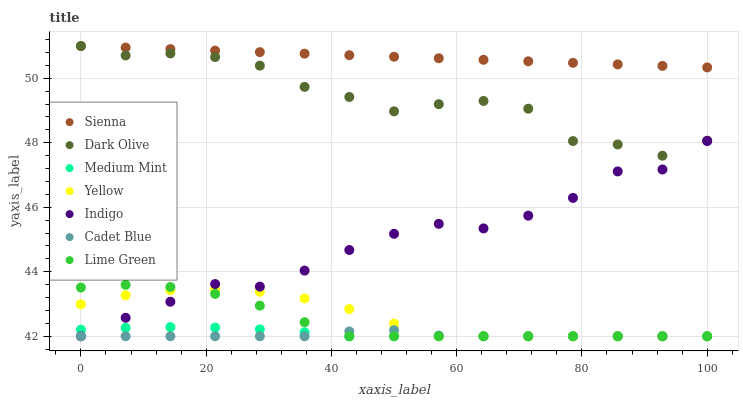Does Cadet Blue have the minimum area under the curve?
Answer yes or no. Yes. Does Sienna have the maximum area under the curve?
Answer yes or no. Yes. Does Indigo have the minimum area under the curve?
Answer yes or no. No. Does Indigo have the maximum area under the curve?
Answer yes or no. No. Is Sienna the smoothest?
Answer yes or no. Yes. Is Dark Olive the roughest?
Answer yes or no. Yes. Is Cadet Blue the smoothest?
Answer yes or no. No. Is Cadet Blue the roughest?
Answer yes or no. No. Does Medium Mint have the lowest value?
Answer yes or no. Yes. Does Dark Olive have the lowest value?
Answer yes or no. No. Does Sienna have the highest value?
Answer yes or no. Yes. Does Indigo have the highest value?
Answer yes or no. No. Is Medium Mint less than Sienna?
Answer yes or no. Yes. Is Dark Olive greater than Indigo?
Answer yes or no. Yes. Does Indigo intersect Cadet Blue?
Answer yes or no. Yes. Is Indigo less than Cadet Blue?
Answer yes or no. No. Is Indigo greater than Cadet Blue?
Answer yes or no. No. Does Medium Mint intersect Sienna?
Answer yes or no. No. 